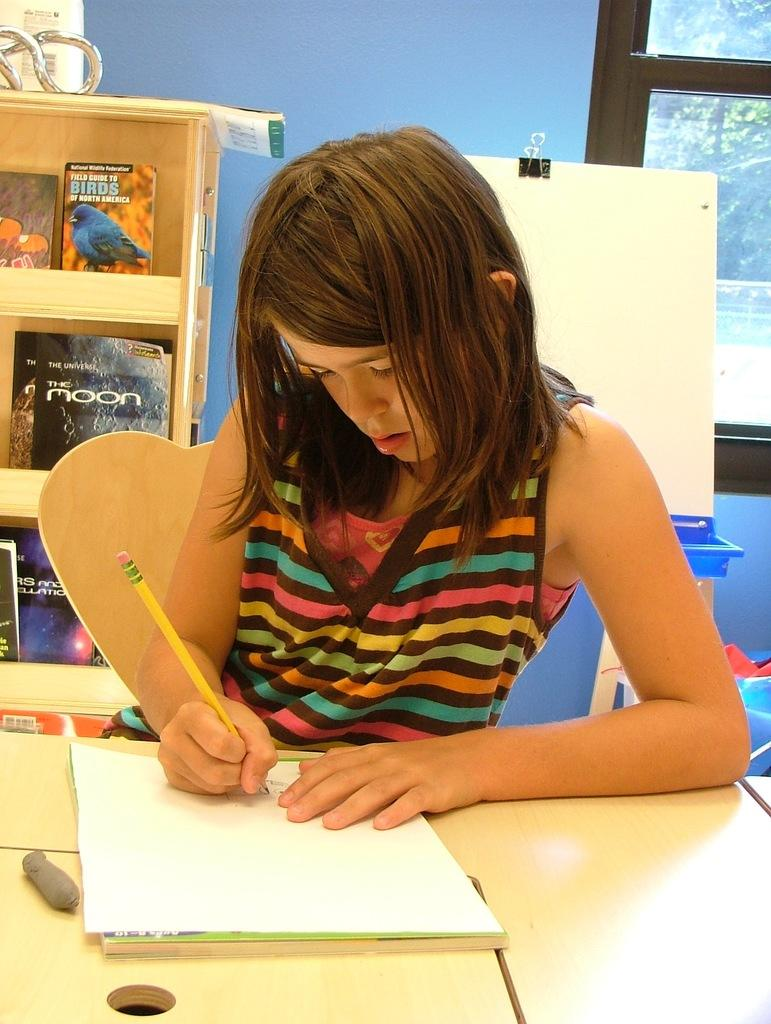Who is the main subject in the image? There is a girl in the image. What is the girl doing in the image? The girl is seated on a chair and writing on a paper with a pencil. What other objects can be seen in the image? There is a table and a bookshelf in the image. What type of good-bye is the girl saying to the band in the image? There is no band present in the image, and the girl is not saying good-bye to anyone. 